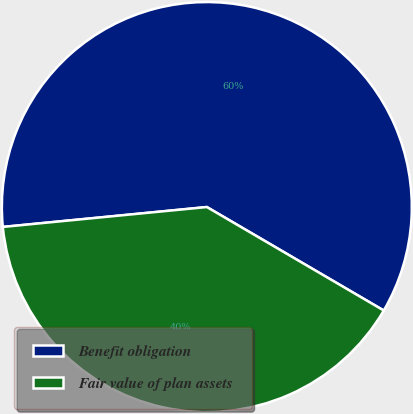<chart> <loc_0><loc_0><loc_500><loc_500><pie_chart><fcel>Benefit obligation<fcel>Fair value of plan assets<nl><fcel>59.97%<fcel>40.03%<nl></chart> 